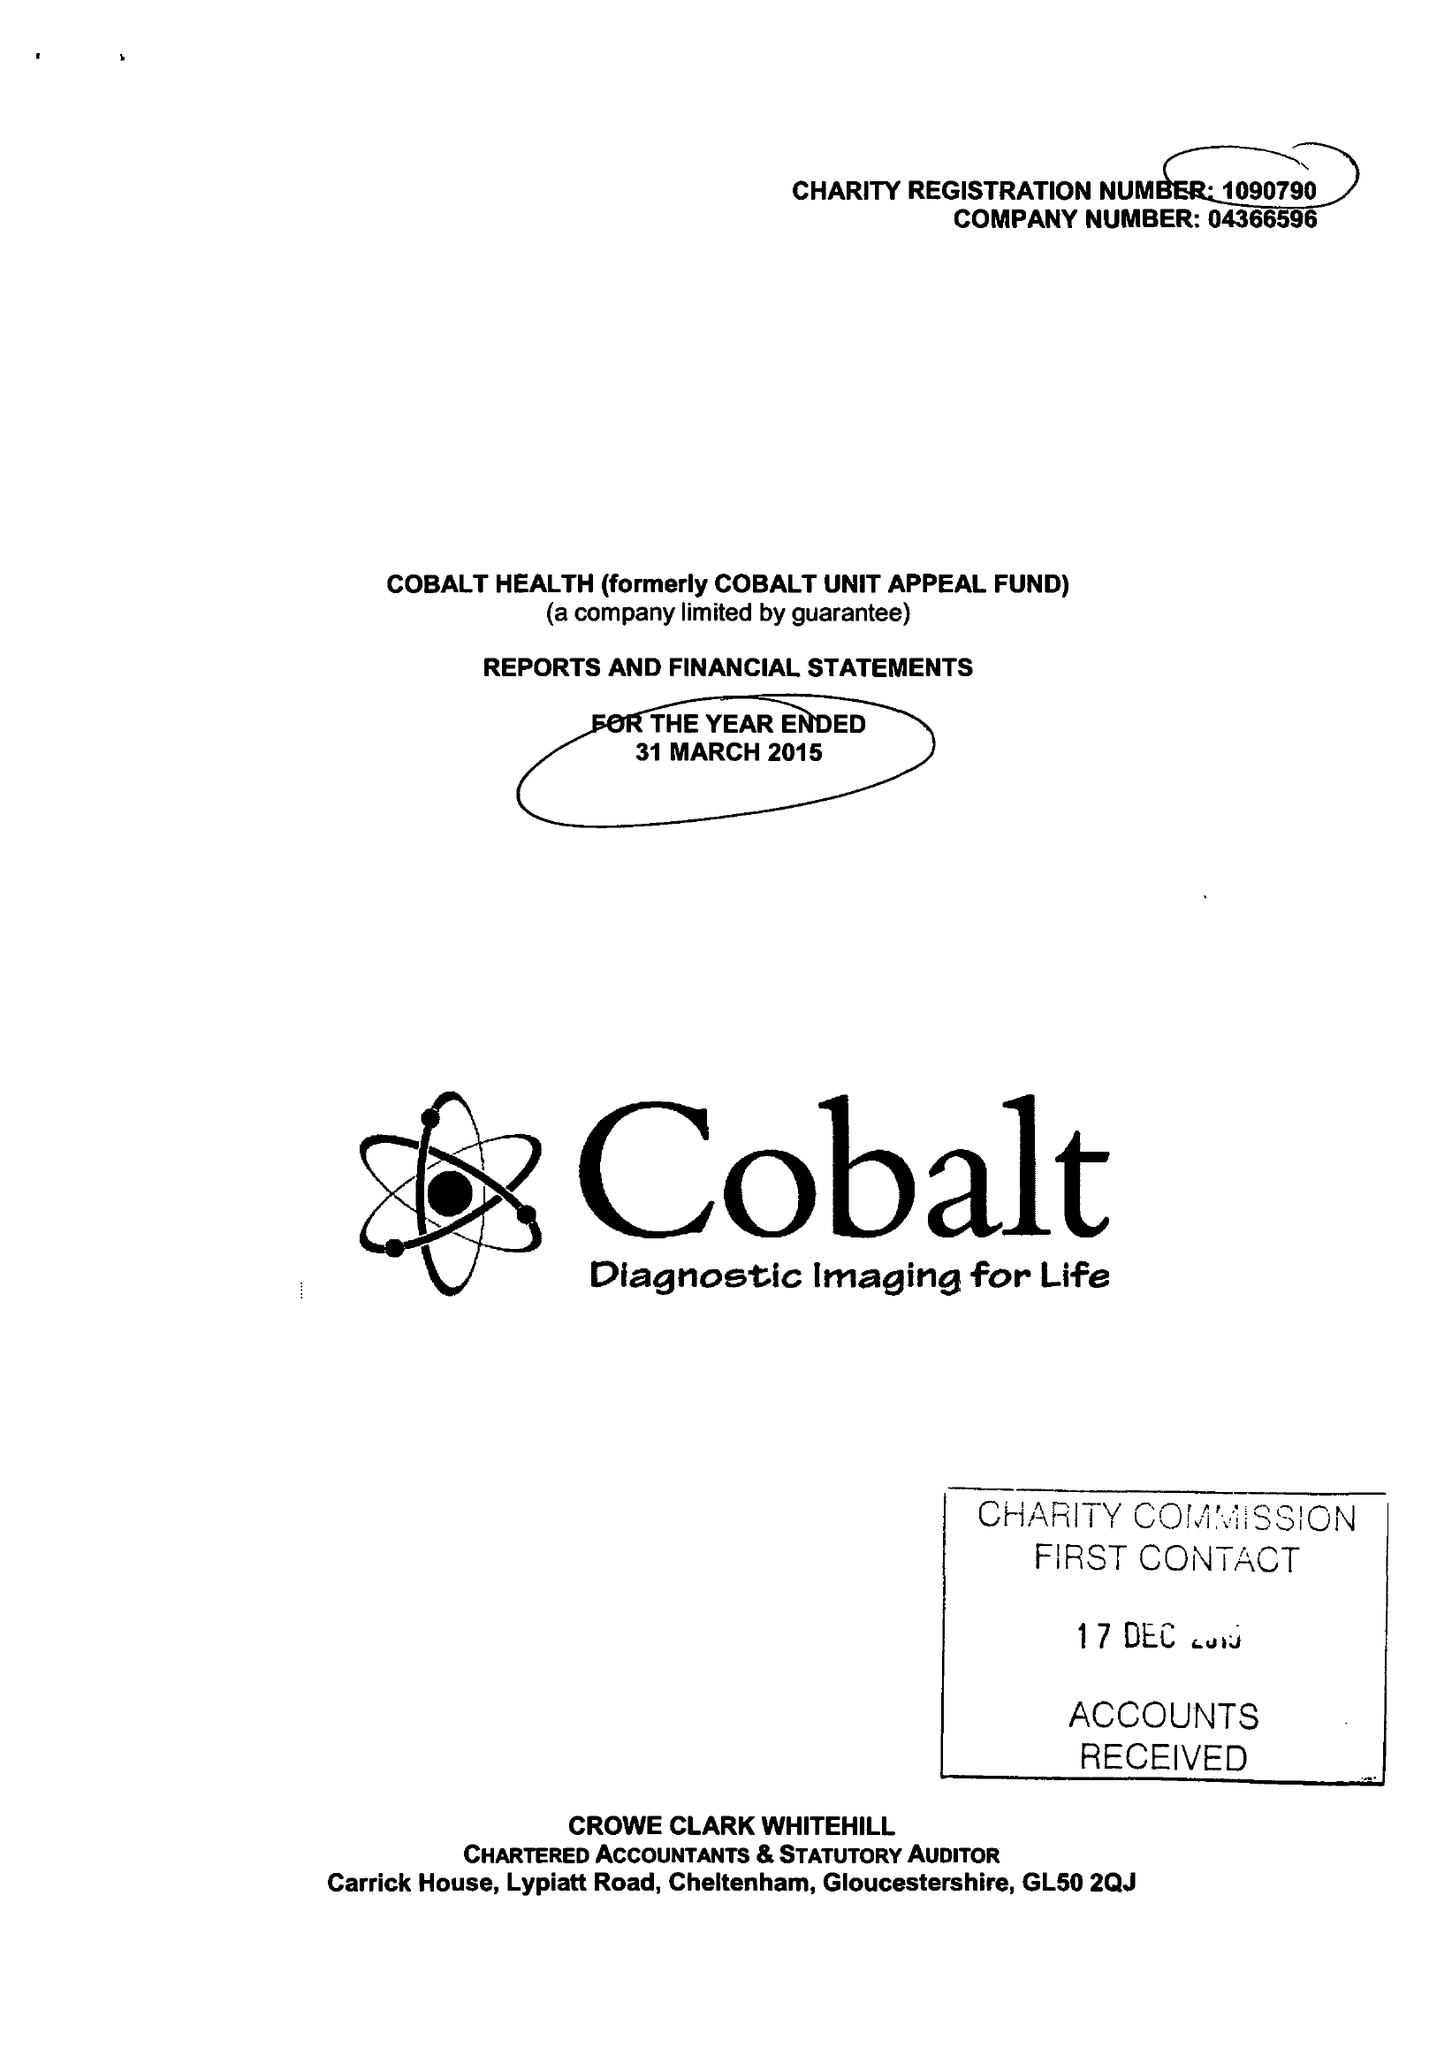What is the value for the address__street_line?
Answer the question using a single word or phrase. THIRLESTAINE ROAD 